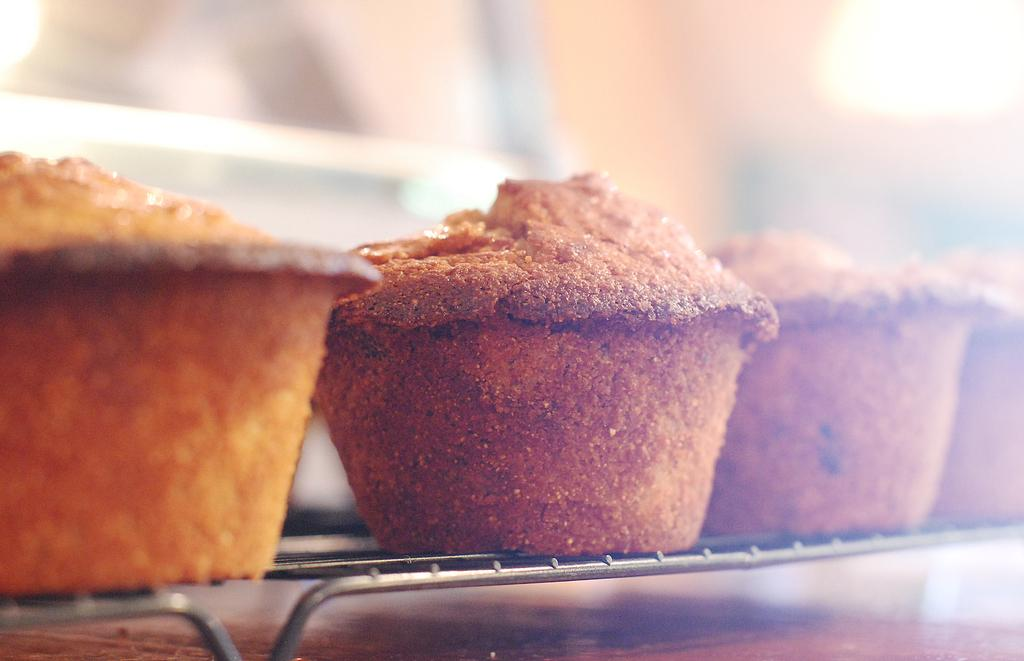What type of food is present in the image? There are cupcakes in the image. Can you describe the background of the image? The background of the image is blurred. How many beds can be seen in the image? There are no beds present in the image; it only features cupcakes. What type of bag is hanging on the shelf in the image? There is no shelf or bag present in the image; it only features cupcakes. 